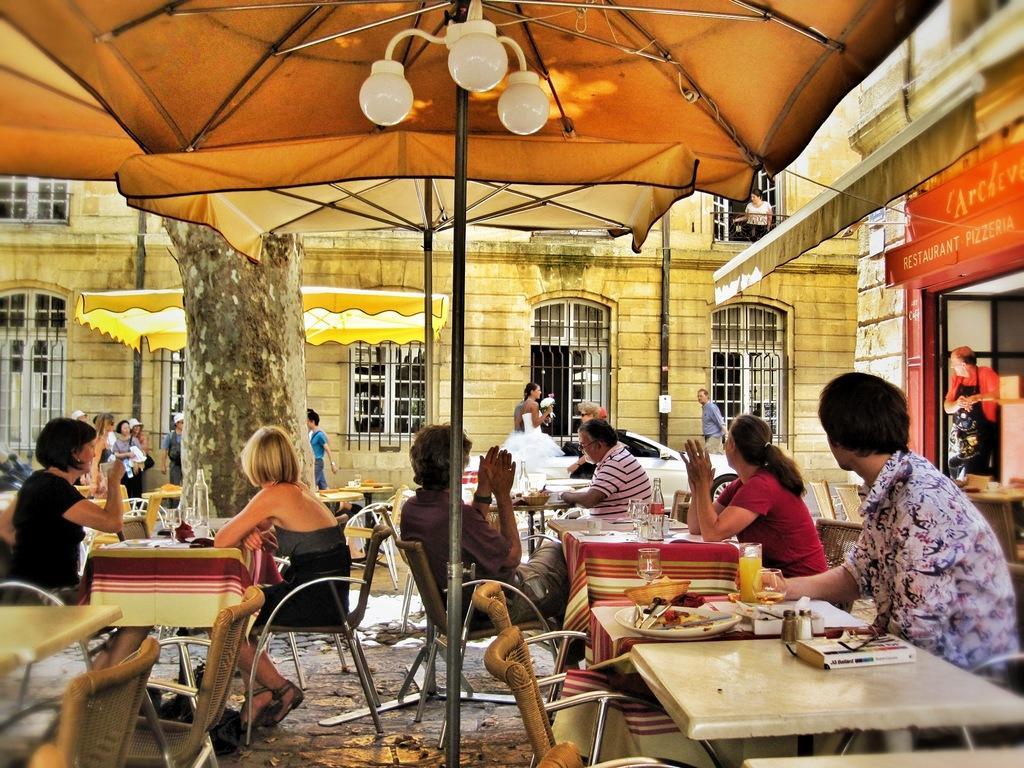How would you summarize this image in a sentence or two? This image is clicked outside. There is a building in the middle. There is a tent on the top. There are lights on the top. There are so many tables in this image, people are sitting around the tables and chairs. There are plates, glasses, books, bottles on this table. There are Windows to that building. There is a tree on the left side. 